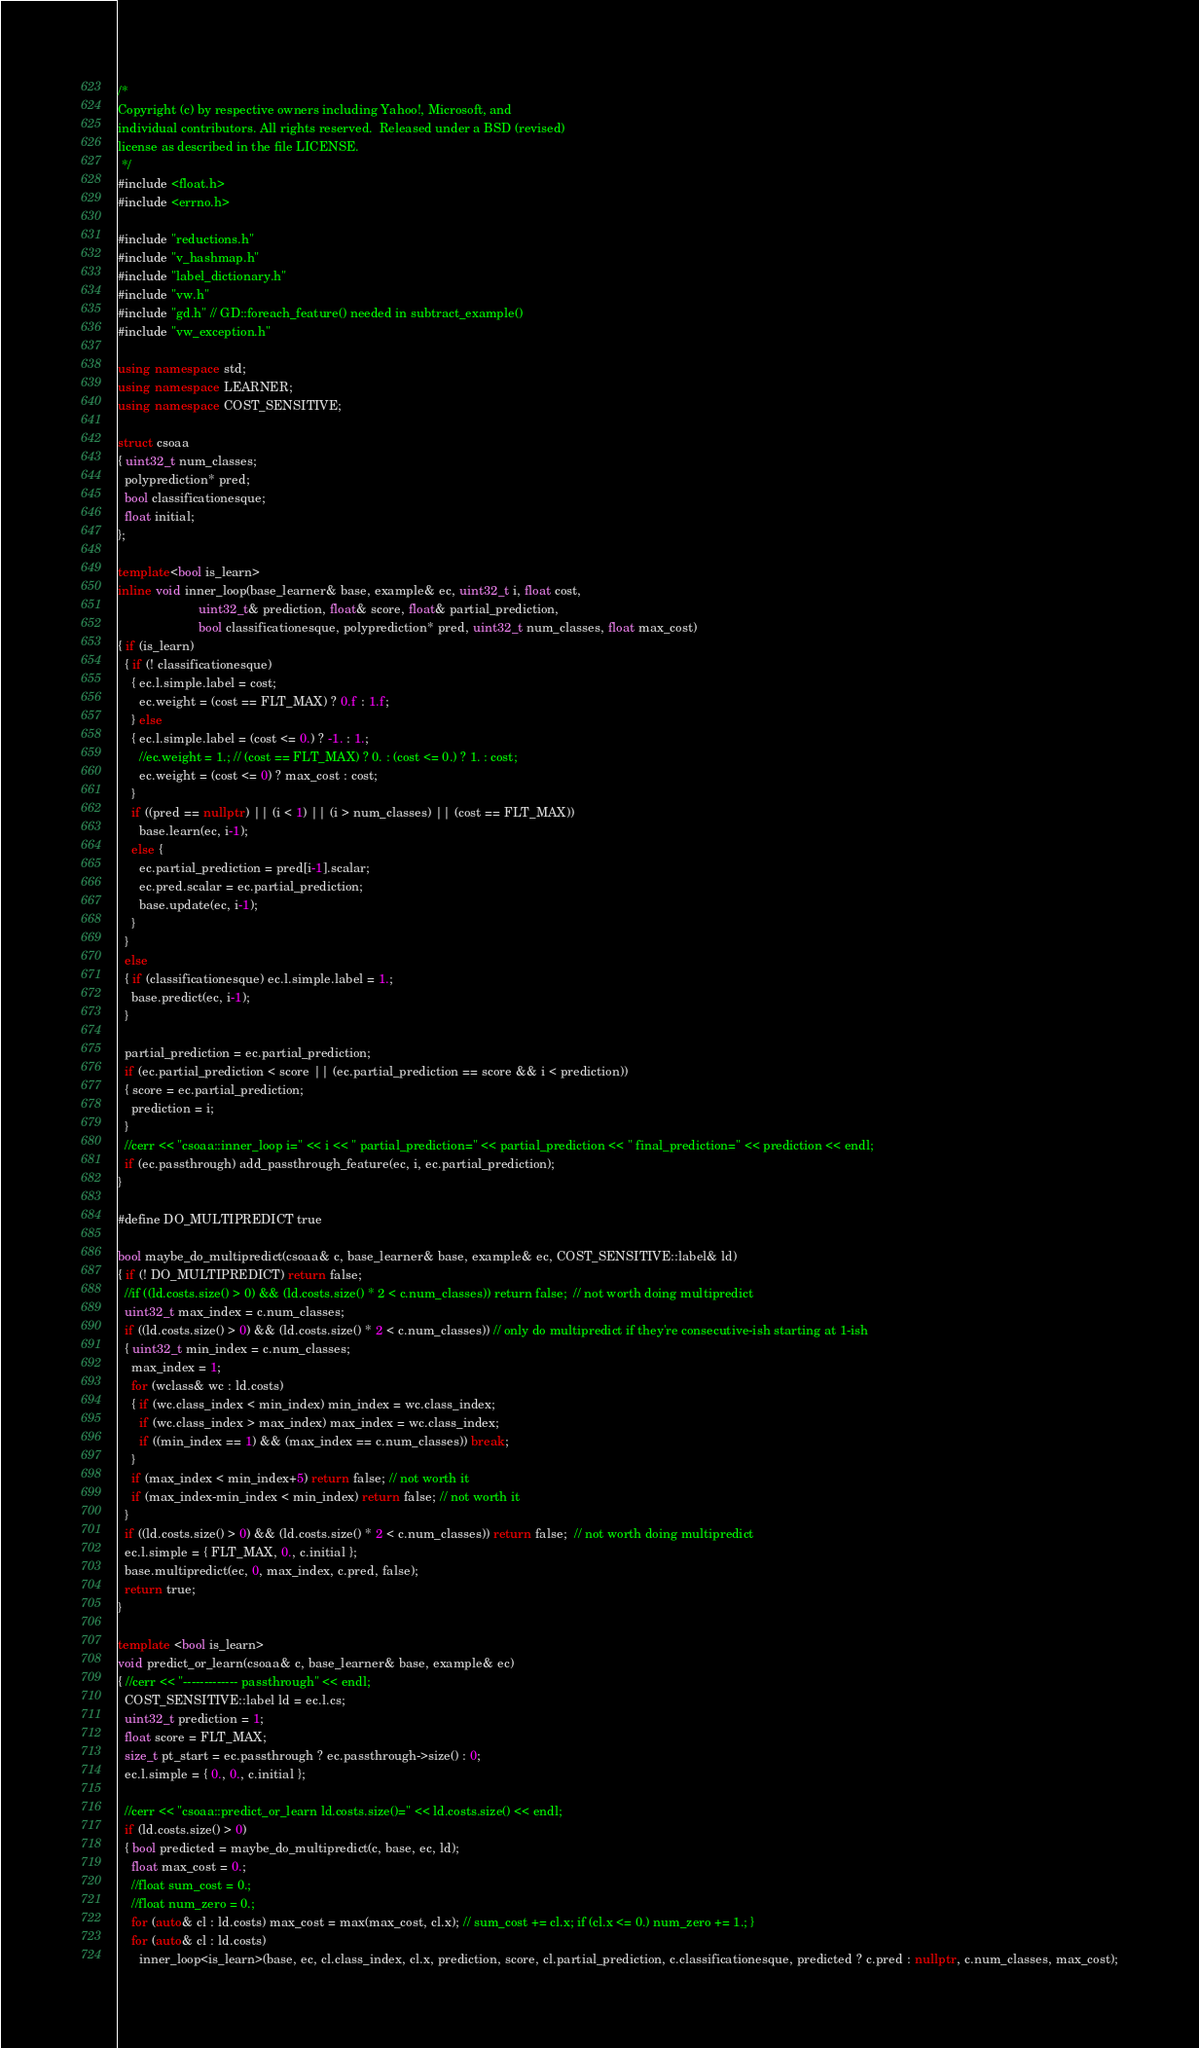<code> <loc_0><loc_0><loc_500><loc_500><_C++_>/*
Copyright (c) by respective owners including Yahoo!, Microsoft, and
individual contributors. All rights reserved.  Released under a BSD (revised)
license as described in the file LICENSE.
 */
#include <float.h>
#include <errno.h>

#include "reductions.h"
#include "v_hashmap.h"
#include "label_dictionary.h"
#include "vw.h"
#include "gd.h" // GD::foreach_feature() needed in subtract_example()
#include "vw_exception.h"

using namespace std;
using namespace LEARNER;
using namespace COST_SENSITIVE;

struct csoaa
{ uint32_t num_classes;
  polyprediction* pred;
  bool classificationesque;
  float initial;
};

template<bool is_learn>
inline void inner_loop(base_learner& base, example& ec, uint32_t i, float cost,
                       uint32_t& prediction, float& score, float& partial_prediction,
                       bool classificationesque, polyprediction* pred, uint32_t num_classes, float max_cost)
{ if (is_learn)
  { if (! classificationesque)
    { ec.l.simple.label = cost;
      ec.weight = (cost == FLT_MAX) ? 0.f : 1.f;
    } else
    { ec.l.simple.label = (cost <= 0.) ? -1. : 1.;
      //ec.weight = 1.; // (cost == FLT_MAX) ? 0. : (cost <= 0.) ? 1. : cost;
      ec.weight = (cost <= 0) ? max_cost : cost;
    }
    if ((pred == nullptr) || (i < 1) || (i > num_classes) || (cost == FLT_MAX))
      base.learn(ec, i-1);
    else {
      ec.partial_prediction = pred[i-1].scalar;
      ec.pred.scalar = ec.partial_prediction;
      base.update(ec, i-1);
    }
  }
  else
  { if (classificationesque) ec.l.simple.label = 1.;
    base.predict(ec, i-1);
  }
  
  partial_prediction = ec.partial_prediction;
  if (ec.partial_prediction < score || (ec.partial_prediction == score && i < prediction))
  { score = ec.partial_prediction;
    prediction = i;
  }
  //cerr << "csoaa::inner_loop i=" << i << " partial_prediction=" << partial_prediction << " final_prediction=" << prediction << endl;
  if (ec.passthrough) add_passthrough_feature(ec, i, ec.partial_prediction);
}

#define DO_MULTIPREDICT true

bool maybe_do_multipredict(csoaa& c, base_learner& base, example& ec, COST_SENSITIVE::label& ld)
{ if (! DO_MULTIPREDICT) return false;
  //if ((ld.costs.size() > 0) && (ld.costs.size() * 2 < c.num_classes)) return false;  // not worth doing multipredict
  uint32_t max_index = c.num_classes;
  if ((ld.costs.size() > 0) && (ld.costs.size() * 2 < c.num_classes)) // only do multipredict if they're consecutive-ish starting at 1-ish
  { uint32_t min_index = c.num_classes;
    max_index = 1;
    for (wclass& wc : ld.costs)
    { if (wc.class_index < min_index) min_index = wc.class_index;
      if (wc.class_index > max_index) max_index = wc.class_index;
      if ((min_index == 1) && (max_index == c.num_classes)) break;
    }
    if (max_index < min_index+5) return false; // not worth it
    if (max_index-min_index < min_index) return false; // not worth it
  }
  if ((ld.costs.size() > 0) && (ld.costs.size() * 2 < c.num_classes)) return false;  // not worth doing multipredict
  ec.l.simple = { FLT_MAX, 0., c.initial };
  base.multipredict(ec, 0, max_index, c.pred, false);
  return true;
}

template <bool is_learn>
void predict_or_learn(csoaa& c, base_learner& base, example& ec)
{ //cerr << "------------- passthrough" << endl;
  COST_SENSITIVE::label ld = ec.l.cs;
  uint32_t prediction = 1;
  float score = FLT_MAX;
  size_t pt_start = ec.passthrough ? ec.passthrough->size() : 0;
  ec.l.simple = { 0., 0., c.initial };

  //cerr << "csoaa::predict_or_learn ld.costs.size()=" << ld.costs.size() << endl;
  if (ld.costs.size() > 0)
  { bool predicted = maybe_do_multipredict(c, base, ec, ld);
    float max_cost = 0.;
    //float sum_cost = 0.;
    //float num_zero = 0.;
    for (auto& cl : ld.costs) max_cost = max(max_cost, cl.x); // sum_cost += cl.x; if (cl.x <= 0.) num_zero += 1.; }
    for (auto& cl : ld.costs)
      inner_loop<is_learn>(base, ec, cl.class_index, cl.x, prediction, score, cl.partial_prediction, c.classificationesque, predicted ? c.pred : nullptr, c.num_classes, max_cost);</code> 